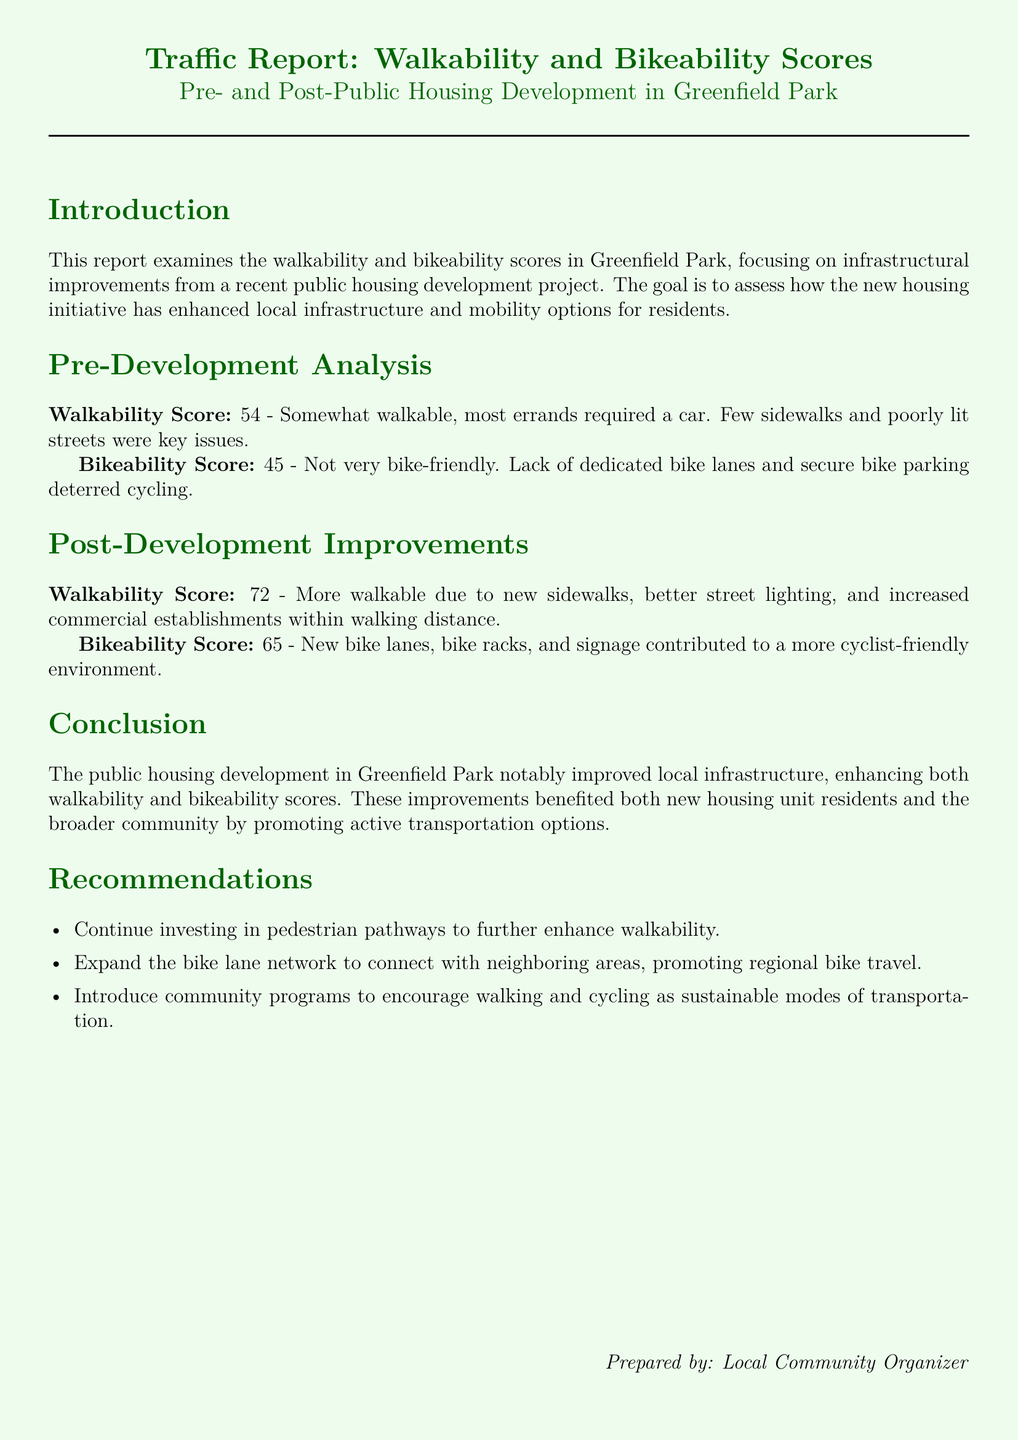What is the walkability score before development? The walkability score before development is explicitly stated in the document under "Pre-Development Analysis".
Answer: 54 What is the bikeability score after development? The bikeability score after development is detailed in the "Post-Development Improvements" section.
Answer: 65 What improvements contributed to the increase in walkability? The document lists specific improvements under "Post-Development Improvements" that enhanced walkability.
Answer: New sidewalks, better street lighting, and increased commercial establishments What is the main goal of the report? The goal of the report is stated in the introduction, summarizing the purpose of the analysis.
Answer: Assess how the new housing initiative has enhanced local infrastructure How is the post-development bikeability score different from the pre-development score? The difference can be calculated by comparing the scores provided in both the "Pre-Development Analysis" and "Post-Development Improvements" sections.
Answer: Increased by 20 What document type is this text? The structure and content suggest a specific type of analysis and reporting focused on urban development.
Answer: Traffic report Which community should programs target to promote active transportation? The recommendation section outlines a target population for the suggested community programs.
Answer: Both new housing unit residents and the broader community What recommendation is made regarding pedestrian pathways? The "Recommendations" section presents various suggestions aiming to improve mobility; one suggests specific action.
Answer: Continue investing in pedestrian pathways 